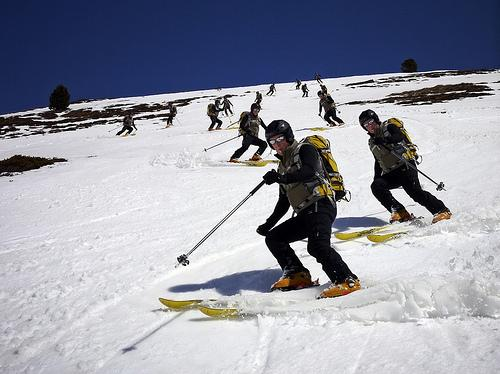Outline the image's focal point, concentrating on the actions of the people involved. The focal point is a group of men skiing down a hill, all actively participating in this exhilarating winter sport. Express the state of the snow and the presence of other elements on the ground. The snow on the ground partially covers dirt, revealing grass, and casts shadows, including that of a skier at an angle. Comment on the equipment used by the skiers, focusing on the main skier. The main skier is wearing yellow skis, a black helmet, and holding a silver ski pole, as well as ski shoes and glasses. Provide a brief overview of the scene depicted in the image. A group of skiers are skiing down a snowy hill with trees in the background, under a clear blue sky. Describe the appearance of the main skier in the foreground. The main skier is wearing a black helmet, ski glasses, a yellow backpack, and black pants. They are holding a silver ski pole. Mention the color of the sky and the state of the snow in the image. The sky is blue and the snow on the ground is partially covering the dirt, revealing some grass. Narrate the scene focusing on the number of people skiing. Several people, including a main skier in the center, are skiing down the slope, all enjoying the winter activity together. Portray the image by focusing on the skier's attire and accessories. The skier dons a black helmet, ski glasses, a yellow backpack, and black pants, while gripping a silver ski pole and showcasing yellow skis. Provide insight into the skiers' clothing and accessories. The skiers, including the main skier, are seen wearing helmets, ski shoes, and glasses, with the main one carrying a yellow backpack. 